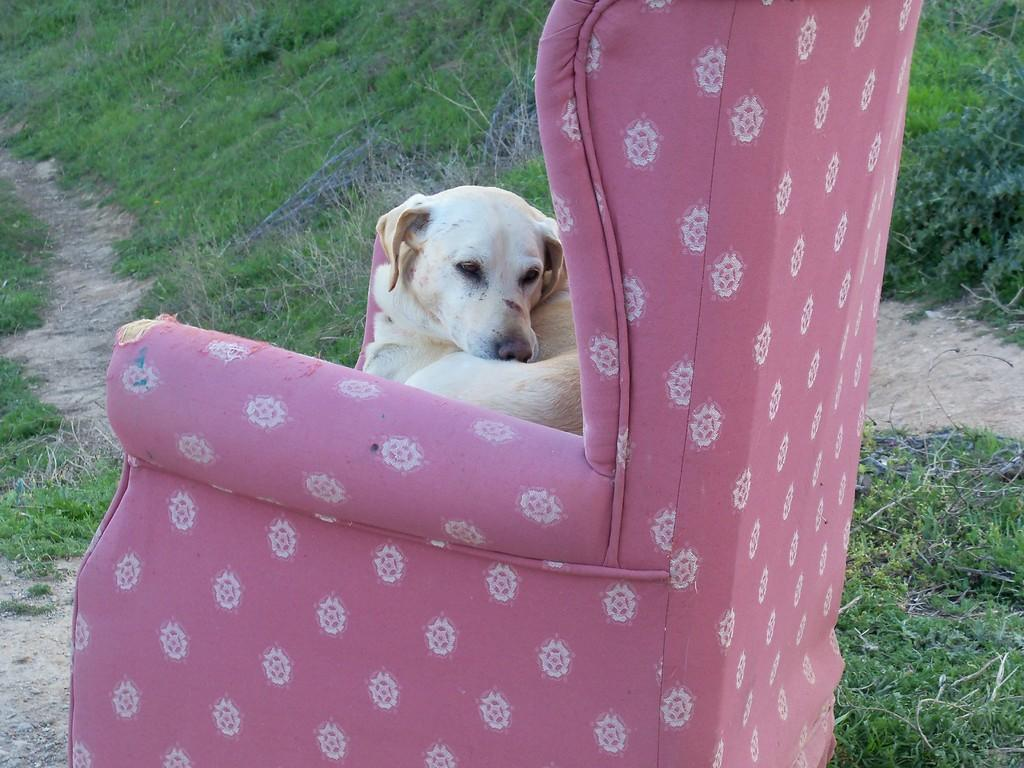What type of furniture is in the image? There is a pink sofa chair in the image. What is on the sofa chair? A cream-colored dog is on the sofa chair. What can be seen in the background of the image? There is grass visible in the background of the image. How many giants are playing with the pump in the image? There are no giants or pumps present in the image. 